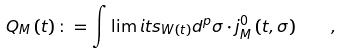Convert formula to latex. <formula><loc_0><loc_0><loc_500><loc_500>Q _ { M } \left ( t \right ) \colon = \int \lim i t s _ { W \left ( t \right ) } d ^ { p } \sigma \cdot j _ { M } ^ { 0 } \left ( t , \sigma \right ) \quad ,</formula> 